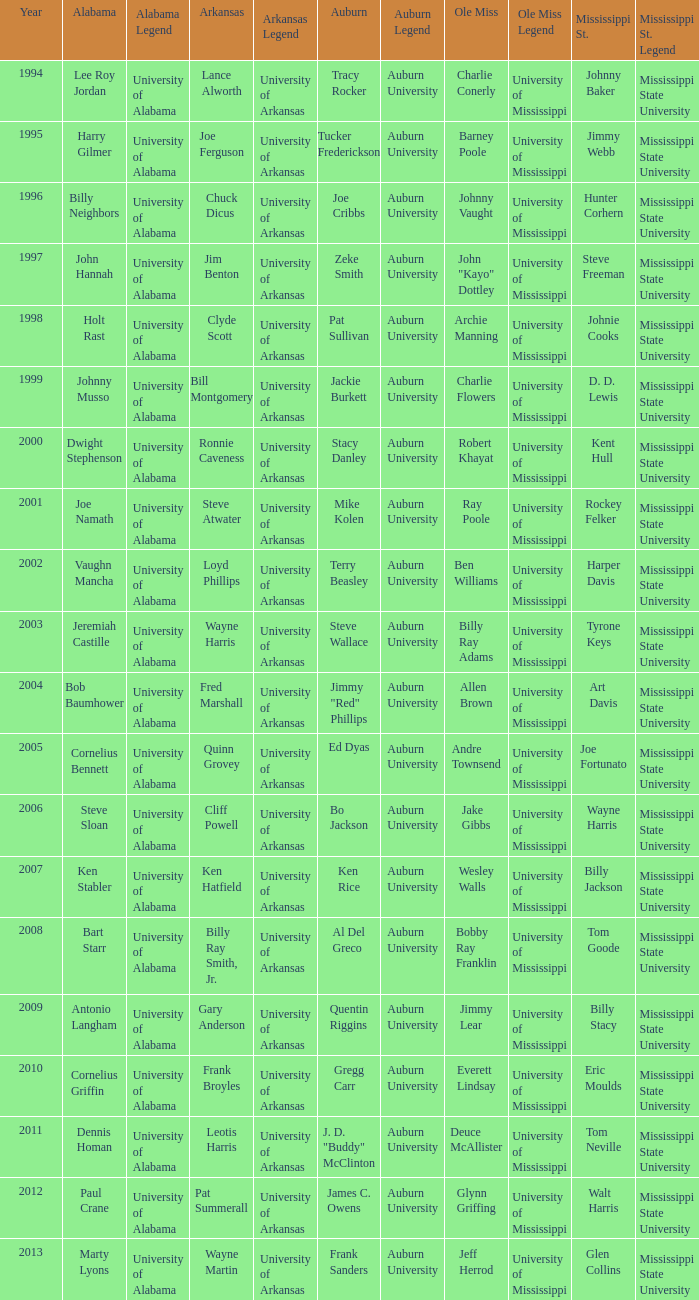Who is the Arkansas player associated with Ken Stabler? Ken Hatfield. 